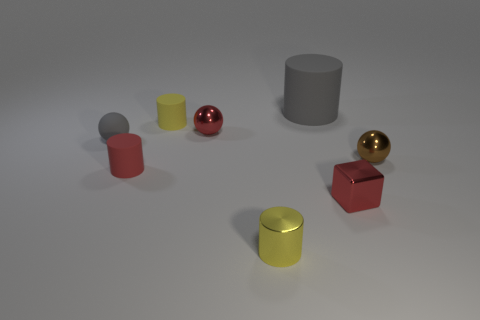Is there any other thing that is the same size as the gray rubber cylinder?
Your answer should be compact. No. The thing that is the same color as the tiny metal cylinder is what shape?
Keep it short and to the point. Cylinder. How many objects are gray rubber objects that are in front of the big gray rubber cylinder or tiny matte cylinders that are left of the small shiny cylinder?
Give a very brief answer. 3. What material is the small yellow cylinder that is behind the ball that is right of the big gray thing made of?
Give a very brief answer. Rubber. What number of other things are the same material as the large object?
Make the answer very short. 3. Is the red matte object the same shape as the brown thing?
Give a very brief answer. No. What size is the rubber object that is left of the small red matte object?
Your answer should be compact. Small. There is a yellow shiny cylinder; is its size the same as the rubber object on the left side of the red matte cylinder?
Offer a very short reply. Yes. Are there fewer tiny objects that are behind the small yellow matte object than big purple cylinders?
Your response must be concise. No. What is the material of the gray thing that is the same shape as the tiny red matte object?
Give a very brief answer. Rubber. 